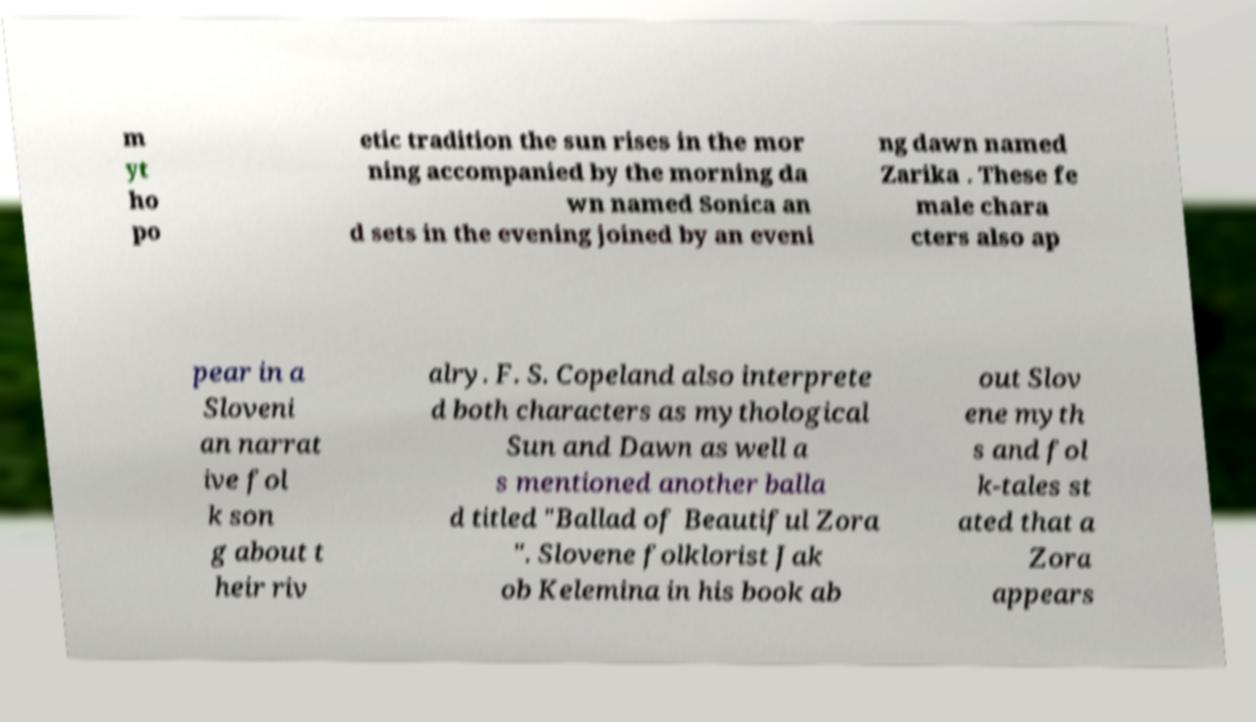Can you read and provide the text displayed in the image?This photo seems to have some interesting text. Can you extract and type it out for me? m yt ho po etic tradition the sun rises in the mor ning accompanied by the morning da wn named Sonica an d sets in the evening joined by an eveni ng dawn named Zarika . These fe male chara cters also ap pear in a Sloveni an narrat ive fol k son g about t heir riv alry. F. S. Copeland also interprete d both characters as mythological Sun and Dawn as well a s mentioned another balla d titled "Ballad of Beautiful Zora ". Slovene folklorist Jak ob Kelemina in his book ab out Slov ene myth s and fol k-tales st ated that a Zora appears 